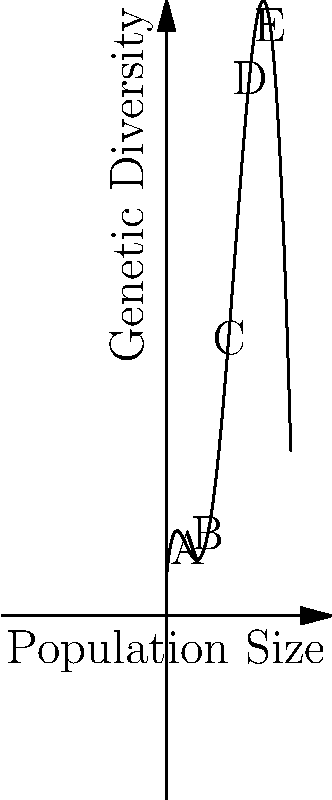The graph shows the relationship between population size and genetic diversity for an endangered species you're studying. The quintic function $f(x) = 0.0001x^5 - 0.01x^4 + 0.3x^3 - 3x^2 + 10x + 10$ represents this relationship, where $x$ is the population size and $f(x)$ is the genetic diversity. At which labeled point (A, B, C, D, or E) does the population show the highest genetic diversity? To determine the point with the highest genetic diversity, we need to compare the y-values (genetic diversity) at each labeled point:

1. Point A: $x = 5$
   $f(5) = 0.0001(5^5) - 0.01(5^4) + 0.3(5^3) - 3(5^2) + 10(5) + 10 = 47.8125$

2. Point B: $x = 10$
   $f(10) = 0.0001(10^5) - 0.01(10^4) + 0.3(10^3) - 3(10^2) + 10(10) + 10 = 110$

3. Point C: $x = 15$
   $f(15) = 0.0001(15^5) - 0.01(15^4) + 0.3(15^3) - 3(15^2) + 10(15) + 10 = 168.4375$

4. Point D: $x = 20$
   $f(20) = 0.0001(20^5) - 0.01(20^4) + 0.3(20^3) - 3(20^2) + 10(20) + 10 = 210$

5. Point E: $x = 25$
   $f(25) = 0.0001(25^5) - 0.01(25^4) + 0.3(25^3) - 3(25^2) + 10(25) + 10 = 234.375$

Comparing these values, we can see that Point E has the highest y-value, corresponding to the highest genetic diversity.
Answer: E 